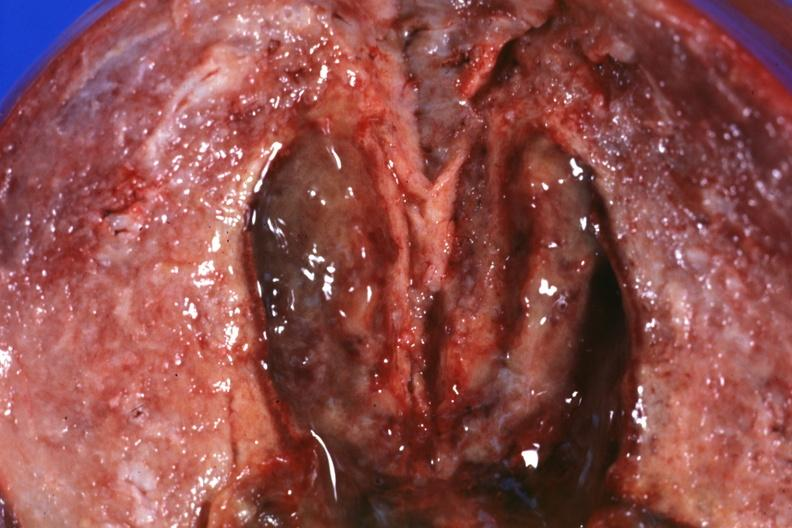does this image show close-up view of 5 weeks post section 29yobf hypertension and brain hemorrhage?
Answer the question using a single word or phrase. Yes 